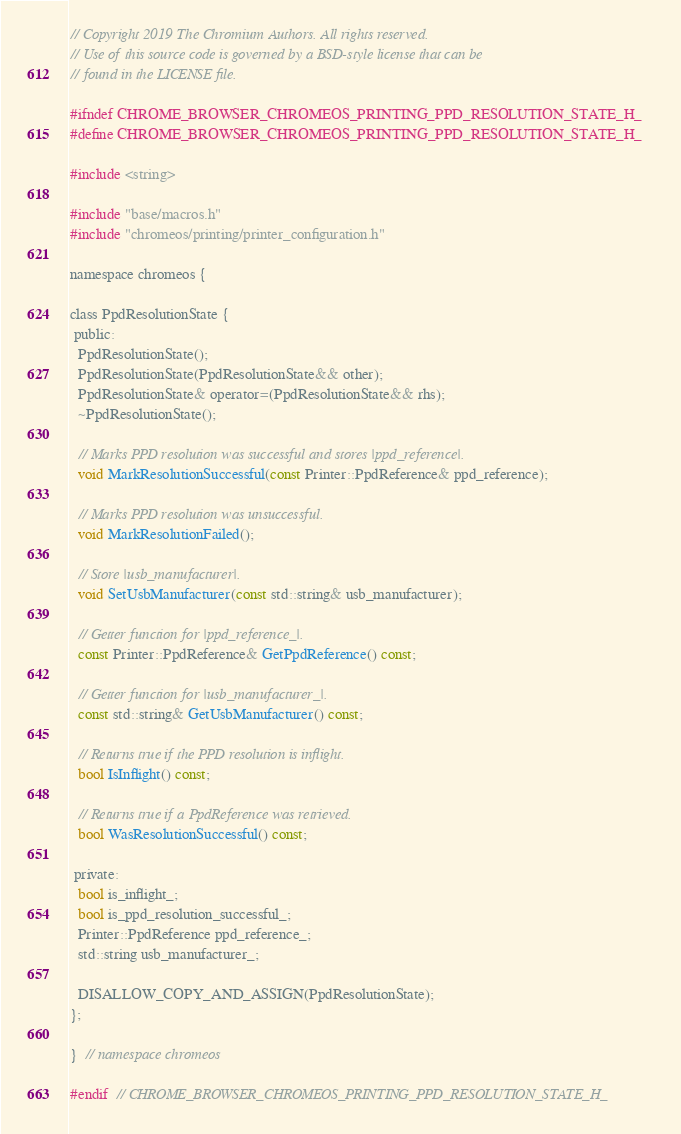Convert code to text. <code><loc_0><loc_0><loc_500><loc_500><_C_>// Copyright 2019 The Chromium Authors. All rights reserved.
// Use of this source code is governed by a BSD-style license that can be
// found in the LICENSE file.

#ifndef CHROME_BROWSER_CHROMEOS_PRINTING_PPD_RESOLUTION_STATE_H_
#define CHROME_BROWSER_CHROMEOS_PRINTING_PPD_RESOLUTION_STATE_H_

#include <string>

#include "base/macros.h"
#include "chromeos/printing/printer_configuration.h"

namespace chromeos {

class PpdResolutionState {
 public:
  PpdResolutionState();
  PpdResolutionState(PpdResolutionState&& other);
  PpdResolutionState& operator=(PpdResolutionState&& rhs);
  ~PpdResolutionState();

  // Marks PPD resolution was successful and stores |ppd_reference|.
  void MarkResolutionSuccessful(const Printer::PpdReference& ppd_reference);

  // Marks PPD resolution was unsuccessful.
  void MarkResolutionFailed();

  // Store |usb_manufacturer|.
  void SetUsbManufacturer(const std::string& usb_manufacturer);

  // Getter function for |ppd_reference_|.
  const Printer::PpdReference& GetPpdReference() const;

  // Getter function for |usb_manufacturer_|.
  const std::string& GetUsbManufacturer() const;

  // Returns true if the PPD resolution is inflight.
  bool IsInflight() const;

  // Returns true if a PpdReference was retrieved.
  bool WasResolutionSuccessful() const;

 private:
  bool is_inflight_;
  bool is_ppd_resolution_successful_;
  Printer::PpdReference ppd_reference_;
  std::string usb_manufacturer_;

  DISALLOW_COPY_AND_ASSIGN(PpdResolutionState);
};

}  // namespace chromeos

#endif  // CHROME_BROWSER_CHROMEOS_PRINTING_PPD_RESOLUTION_STATE_H_
</code> 